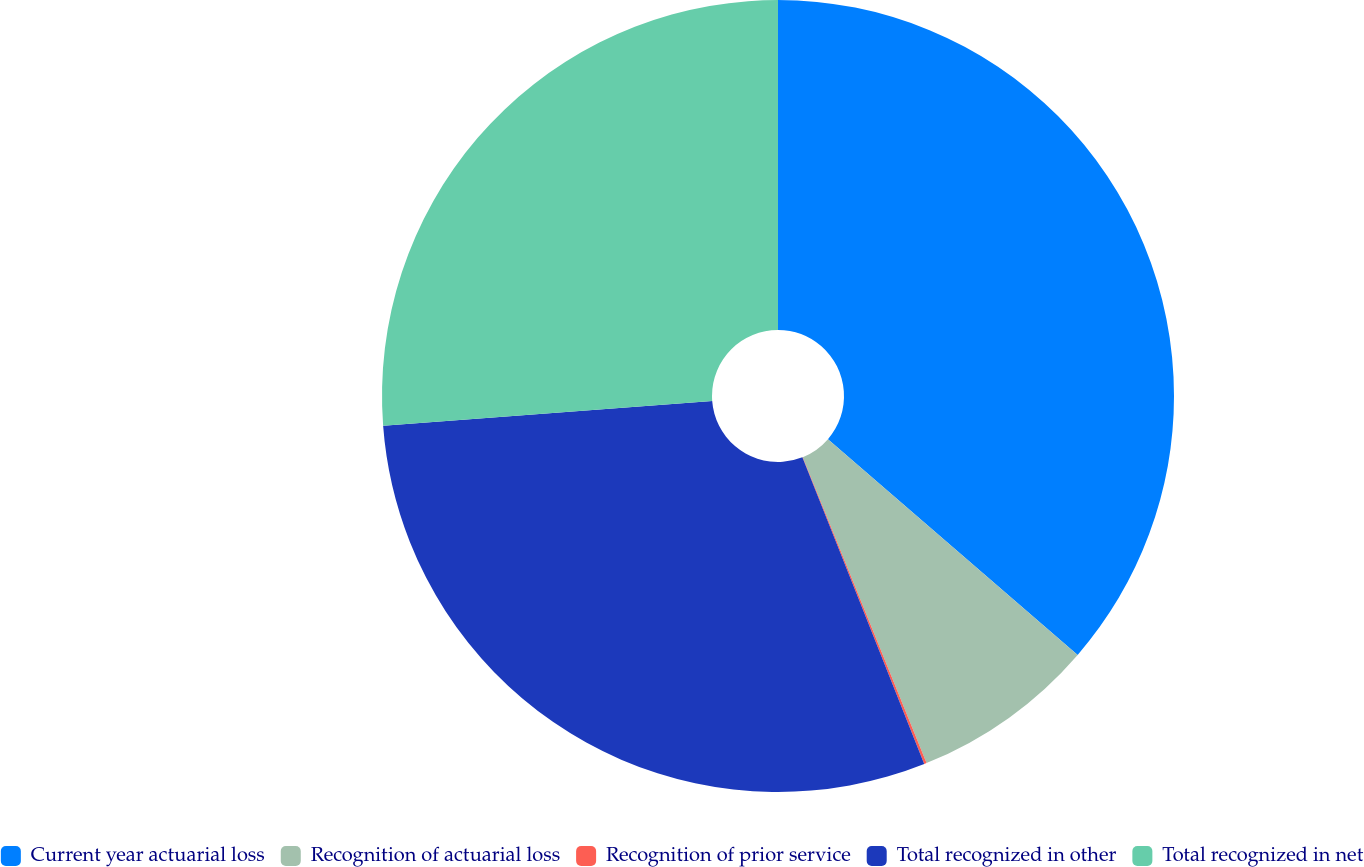Convert chart. <chart><loc_0><loc_0><loc_500><loc_500><pie_chart><fcel>Current year actuarial loss<fcel>Recognition of actuarial loss<fcel>Recognition of prior service<fcel>Total recognized in other<fcel>Total recognized in net<nl><fcel>36.34%<fcel>7.54%<fcel>0.1%<fcel>29.82%<fcel>26.2%<nl></chart> 